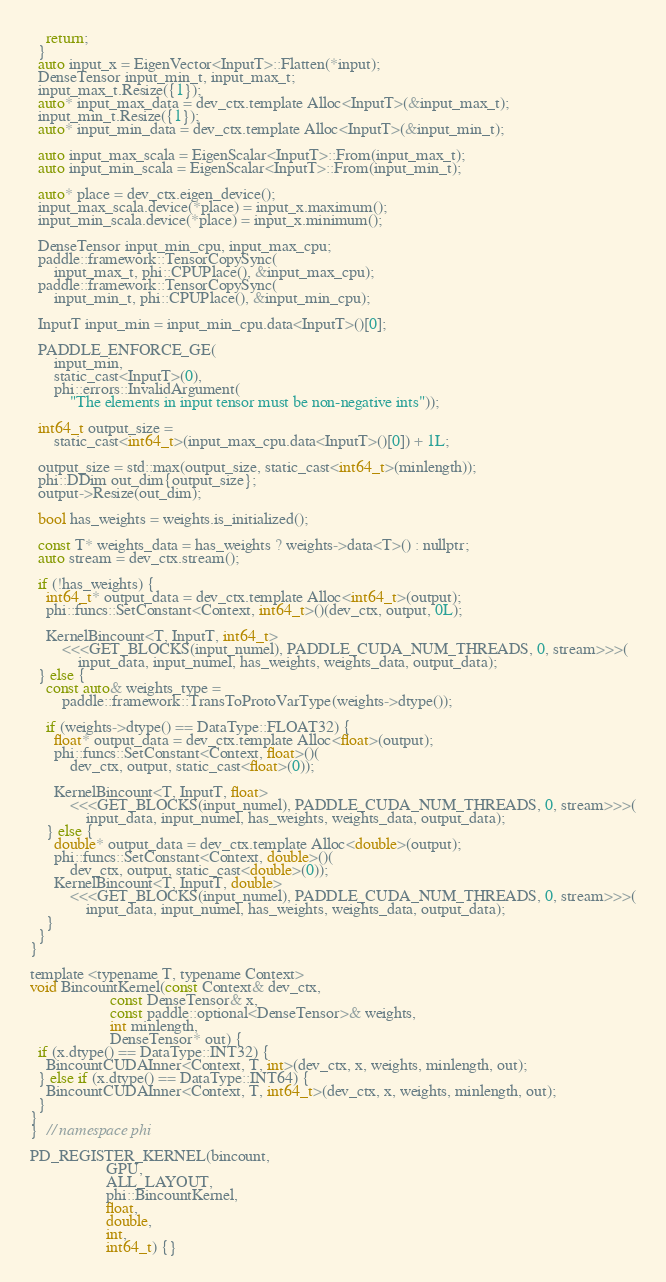Convert code to text. <code><loc_0><loc_0><loc_500><loc_500><_Cuda_>    return;
  }
  auto input_x = EigenVector<InputT>::Flatten(*input);
  DenseTensor input_min_t, input_max_t;
  input_max_t.Resize({1});
  auto* input_max_data = dev_ctx.template Alloc<InputT>(&input_max_t);
  input_min_t.Resize({1});
  auto* input_min_data = dev_ctx.template Alloc<InputT>(&input_min_t);

  auto input_max_scala = EigenScalar<InputT>::From(input_max_t);
  auto input_min_scala = EigenScalar<InputT>::From(input_min_t);

  auto* place = dev_ctx.eigen_device();
  input_max_scala.device(*place) = input_x.maximum();
  input_min_scala.device(*place) = input_x.minimum();

  DenseTensor input_min_cpu, input_max_cpu;
  paddle::framework::TensorCopySync(
      input_max_t, phi::CPUPlace(), &input_max_cpu);
  paddle::framework::TensorCopySync(
      input_min_t, phi::CPUPlace(), &input_min_cpu);

  InputT input_min = input_min_cpu.data<InputT>()[0];

  PADDLE_ENFORCE_GE(
      input_min,
      static_cast<InputT>(0),
      phi::errors::InvalidArgument(
          "The elements in input tensor must be non-negative ints"));

  int64_t output_size =
      static_cast<int64_t>(input_max_cpu.data<InputT>()[0]) + 1L;

  output_size = std::max(output_size, static_cast<int64_t>(minlength));
  phi::DDim out_dim{output_size};
  output->Resize(out_dim);

  bool has_weights = weights.is_initialized();

  const T* weights_data = has_weights ? weights->data<T>() : nullptr;
  auto stream = dev_ctx.stream();

  if (!has_weights) {
    int64_t* output_data = dev_ctx.template Alloc<int64_t>(output);
    phi::funcs::SetConstant<Context, int64_t>()(dev_ctx, output, 0L);

    KernelBincount<T, InputT, int64_t>
        <<<GET_BLOCKS(input_numel), PADDLE_CUDA_NUM_THREADS, 0, stream>>>(
            input_data, input_numel, has_weights, weights_data, output_data);
  } else {
    const auto& weights_type =
        paddle::framework::TransToProtoVarType(weights->dtype());

    if (weights->dtype() == DataType::FLOAT32) {
      float* output_data = dev_ctx.template Alloc<float>(output);
      phi::funcs::SetConstant<Context, float>()(
          dev_ctx, output, static_cast<float>(0));

      KernelBincount<T, InputT, float>
          <<<GET_BLOCKS(input_numel), PADDLE_CUDA_NUM_THREADS, 0, stream>>>(
              input_data, input_numel, has_weights, weights_data, output_data);
    } else {
      double* output_data = dev_ctx.template Alloc<double>(output);
      phi::funcs::SetConstant<Context, double>()(
          dev_ctx, output, static_cast<double>(0));
      KernelBincount<T, InputT, double>
          <<<GET_BLOCKS(input_numel), PADDLE_CUDA_NUM_THREADS, 0, stream>>>(
              input_data, input_numel, has_weights, weights_data, output_data);
    }
  }
}

template <typename T, typename Context>
void BincountKernel(const Context& dev_ctx,
                    const DenseTensor& x,
                    const paddle::optional<DenseTensor>& weights,
                    int minlength,
                    DenseTensor* out) {
  if (x.dtype() == DataType::INT32) {
    BincountCUDAInner<Context, T, int>(dev_ctx, x, weights, minlength, out);
  } else if (x.dtype() == DataType::INT64) {
    BincountCUDAInner<Context, T, int64_t>(dev_ctx, x, weights, minlength, out);
  }
}
}  // namespace phi

PD_REGISTER_KERNEL(bincount,
                   GPU,
                   ALL_LAYOUT,
                   phi::BincountKernel,
                   float,
                   double,
                   int,
                   int64_t) {}
</code> 